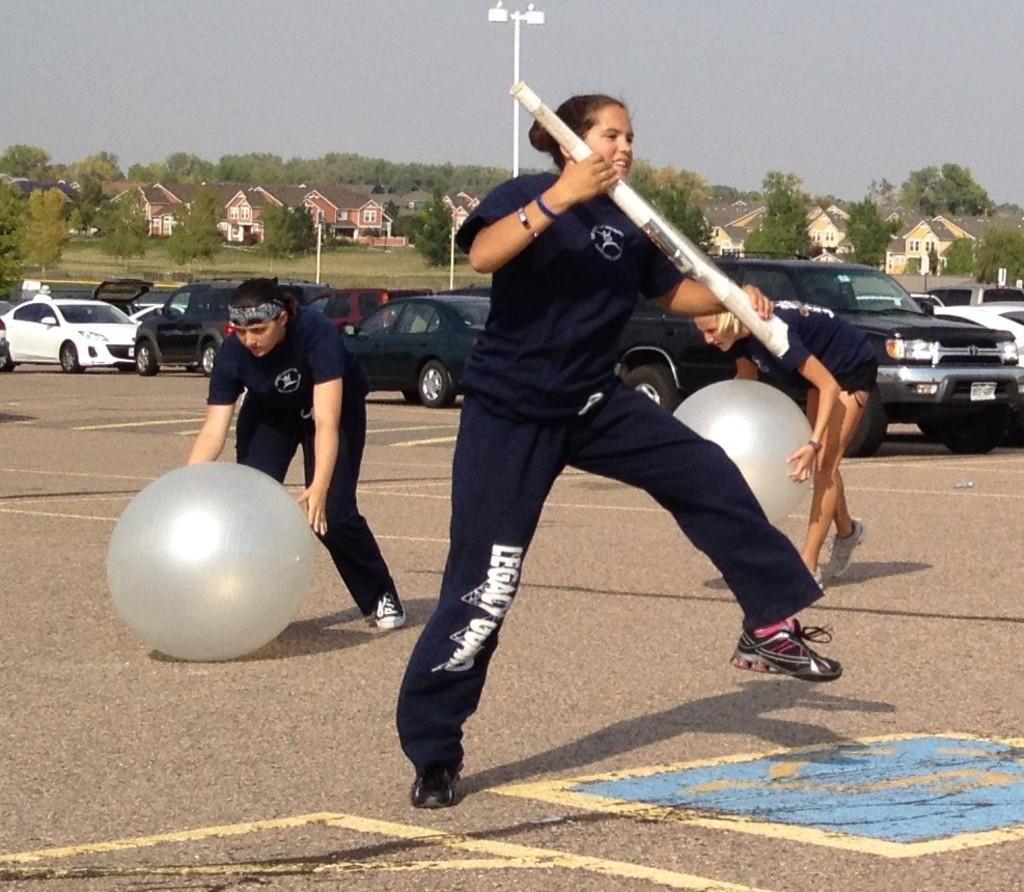Please provide a concise description of this image. In the picture I can see women are standing on the ground among them the woman in the front is holding some object in hands and women in background are holding balloons. In the background I can see houses, poles, vehicles, the sky, trees and some other objects on the ground. 